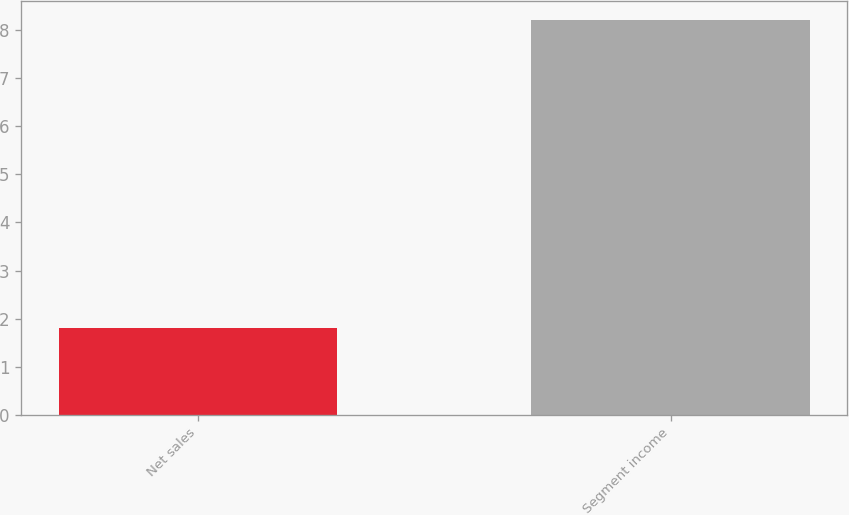Convert chart. <chart><loc_0><loc_0><loc_500><loc_500><bar_chart><fcel>Net sales<fcel>Segment income<nl><fcel>1.8<fcel>8.2<nl></chart> 